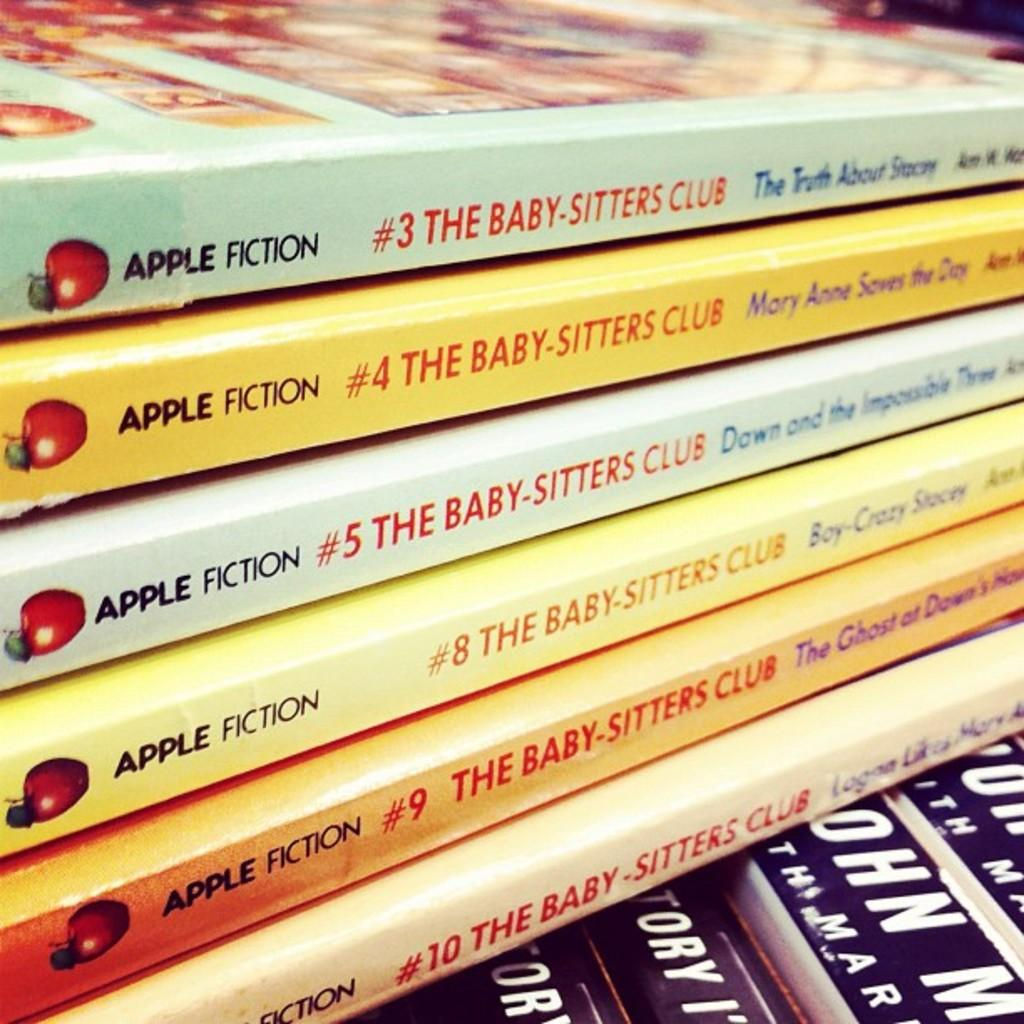Provide a one-sentence caption for the provided image. Six volumes of The Baby-Sitters Club are stacked on top of other books. 